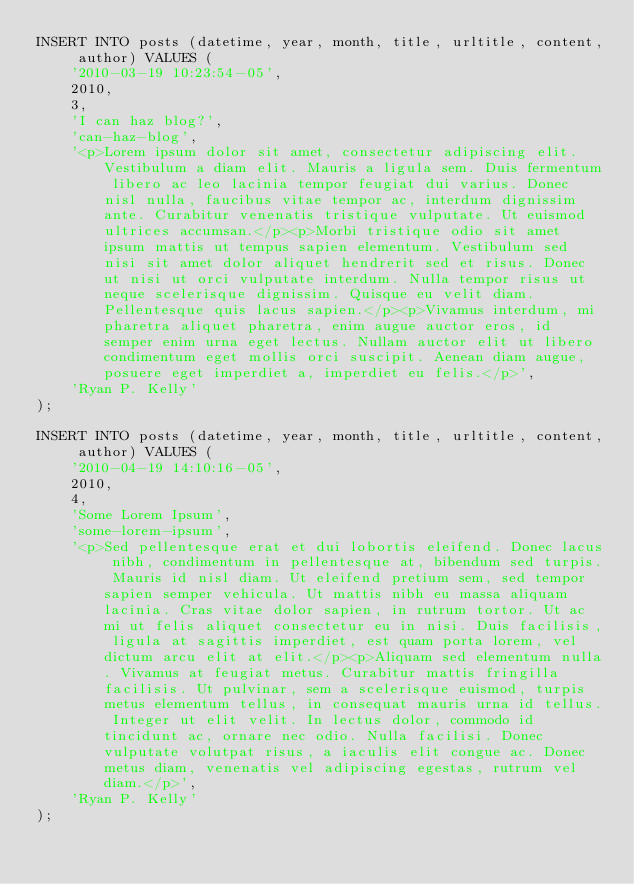<code> <loc_0><loc_0><loc_500><loc_500><_SQL_>INSERT INTO posts (datetime, year, month, title, urltitle, content, author) VALUES (
    '2010-03-19 10:23:54-05',
    2010,
    3,
    'I can haz blog?',
    'can-haz-blog',
    '<p>Lorem ipsum dolor sit amet, consectetur adipiscing elit. Vestibulum a diam elit. Mauris a ligula sem. Duis fermentum libero ac leo lacinia tempor feugiat dui varius. Donec nisl nulla, faucibus vitae tempor ac, interdum dignissim ante. Curabitur venenatis tristique vulputate. Ut euismod ultrices accumsan.</p><p>Morbi tristique odio sit amet ipsum mattis ut tempus sapien elementum. Vestibulum sed nisi sit amet dolor aliquet hendrerit sed et risus. Donec ut nisi ut orci vulputate interdum. Nulla tempor risus ut neque scelerisque dignissim. Quisque eu velit diam. Pellentesque quis lacus sapien.</p><p>Vivamus interdum, mi pharetra aliquet pharetra, enim augue auctor eros, id semper enim urna eget lectus. Nullam auctor elit ut libero condimentum eget mollis orci suscipit. Aenean diam augue, posuere eget imperdiet a, imperdiet eu felis.</p>',
    'Ryan P. Kelly'
);

INSERT INTO posts (datetime, year, month, title, urltitle, content, author) VALUES (
    '2010-04-19 14:10:16-05',
    2010,
    4,
    'Some Lorem Ipsum',
    'some-lorem-ipsum',
    '<p>Sed pellentesque erat et dui lobortis eleifend. Donec lacus nibh, condimentum in pellentesque at, bibendum sed turpis. Mauris id nisl diam. Ut eleifend pretium sem, sed tempor sapien semper vehicula. Ut mattis nibh eu massa aliquam lacinia. Cras vitae dolor sapien, in rutrum tortor. Ut ac mi ut felis aliquet consectetur eu in nisi. Duis facilisis, ligula at sagittis imperdiet, est quam porta lorem, vel dictum arcu elit at elit.</p><p>Aliquam sed elementum nulla. Vivamus at feugiat metus. Curabitur mattis fringilla facilisis. Ut pulvinar, sem a scelerisque euismod, turpis metus elementum tellus, in consequat mauris urna id tellus. Integer ut elit velit. In lectus dolor, commodo id tincidunt ac, ornare nec odio. Nulla facilisi. Donec vulputate volutpat risus, a iaculis elit congue ac. Donec metus diam, venenatis vel adipiscing egestas, rutrum vel diam.</p>',
    'Ryan P. Kelly'
);
</code> 